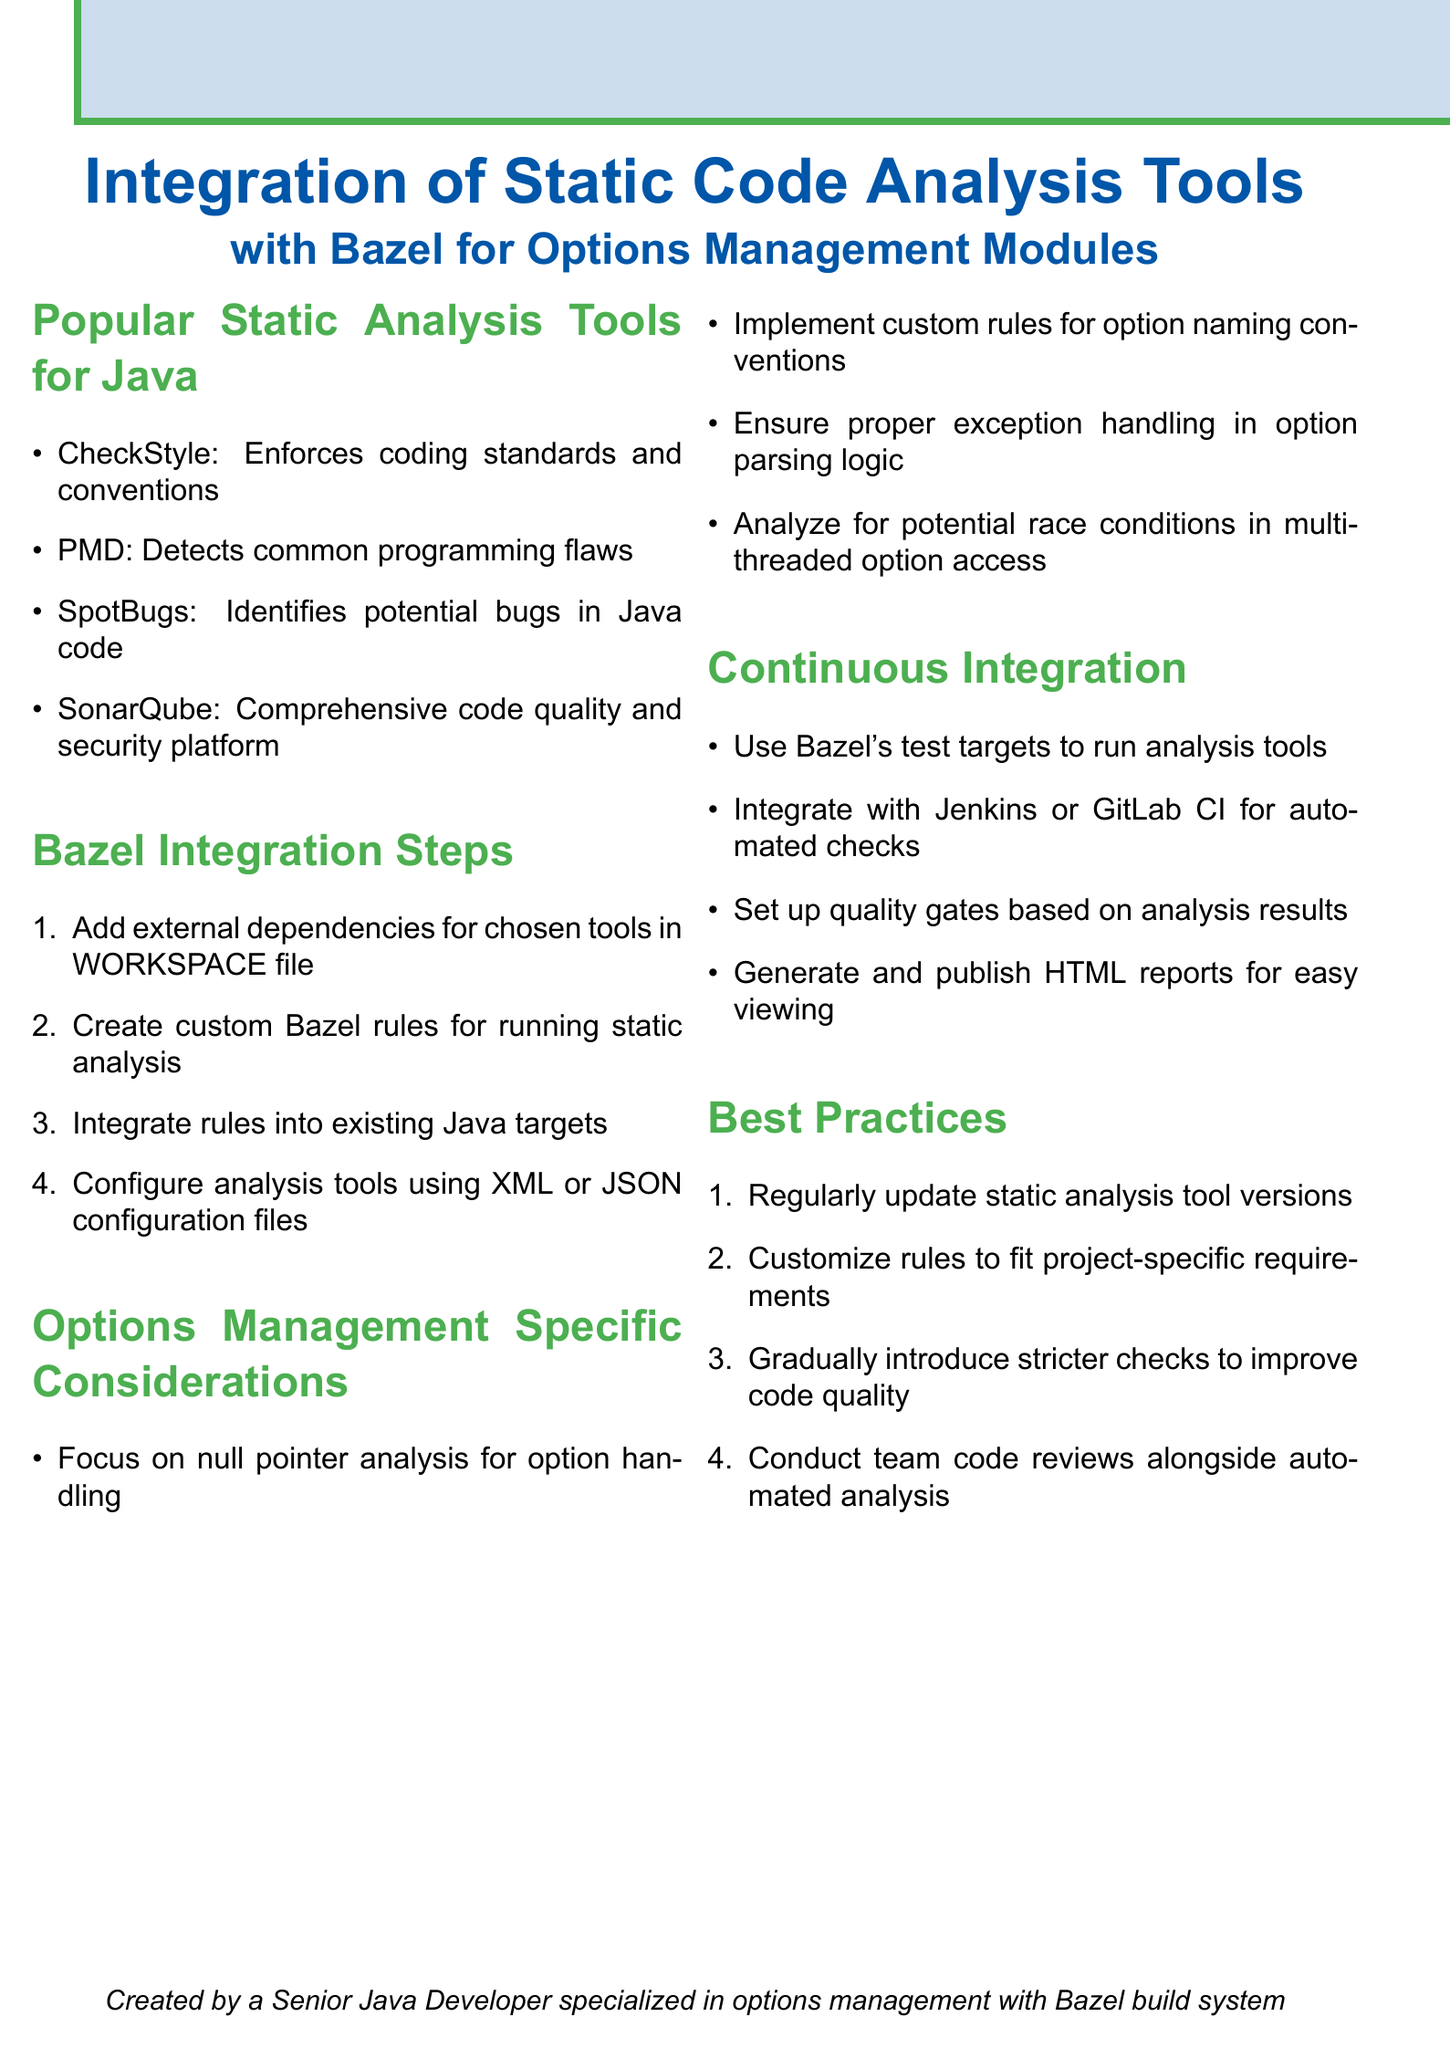What are the popular static analysis tools for Java? The list of popular static analysis tools includes CheckStyle, PMD, SpotBugs, and SonarQube.
Answer: CheckStyle, PMD, SpotBugs, SonarQube What is the first step for Bazel integration? The first step for integrating static code analysis tools with Bazel is to add external dependencies for the chosen tools in the WORKSPACE file.
Answer: Add external dependencies for chosen tools in WORKSPACE file What specific consideration is emphasized for options management? The document emphasizes focusing on null pointer analysis for option handling as a specific consideration for options management.
Answer: Focus on null pointer analysis for option handling Which CI tools can be integrated with Bazel? The document mentions integrating with Jenkins or GitLab CI for automated checks.
Answer: Jenkins, GitLab CI What is a best practice for static analysis tools? One of the best practices mentioned is to regularly update static analysis tool versions.
Answer: Regularly update static analysis tool versions What is the purpose of quality gates? Quality gates are set up based on analysis results to ensure code quality.
Answer: To ensure code quality What format can configuration files be in? Configuration files can be in XML or JSON format according to the document.
Answer: XML or JSON How many best practices are listed? The document lists four best practices for integrating static analysis tools.
Answer: Four 